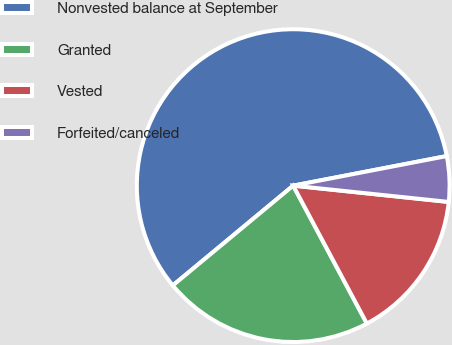Convert chart to OTSL. <chart><loc_0><loc_0><loc_500><loc_500><pie_chart><fcel>Nonvested balance at September<fcel>Granted<fcel>Vested<fcel>Forfeited/canceled<nl><fcel>57.99%<fcel>21.79%<fcel>15.53%<fcel>4.69%<nl></chart> 